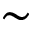<formula> <loc_0><loc_0><loc_500><loc_500>\sim</formula> 